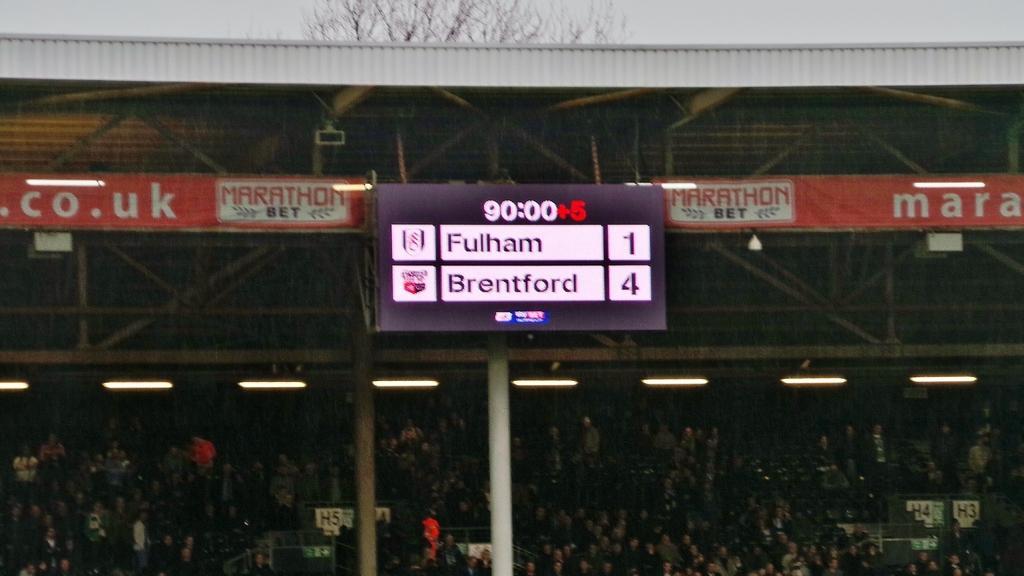Can you describe this image briefly? In this image we can see a group of persons, lights and poles. At the top we can see the roof and banners with text. In the middle we can see a scoreboard with text. 